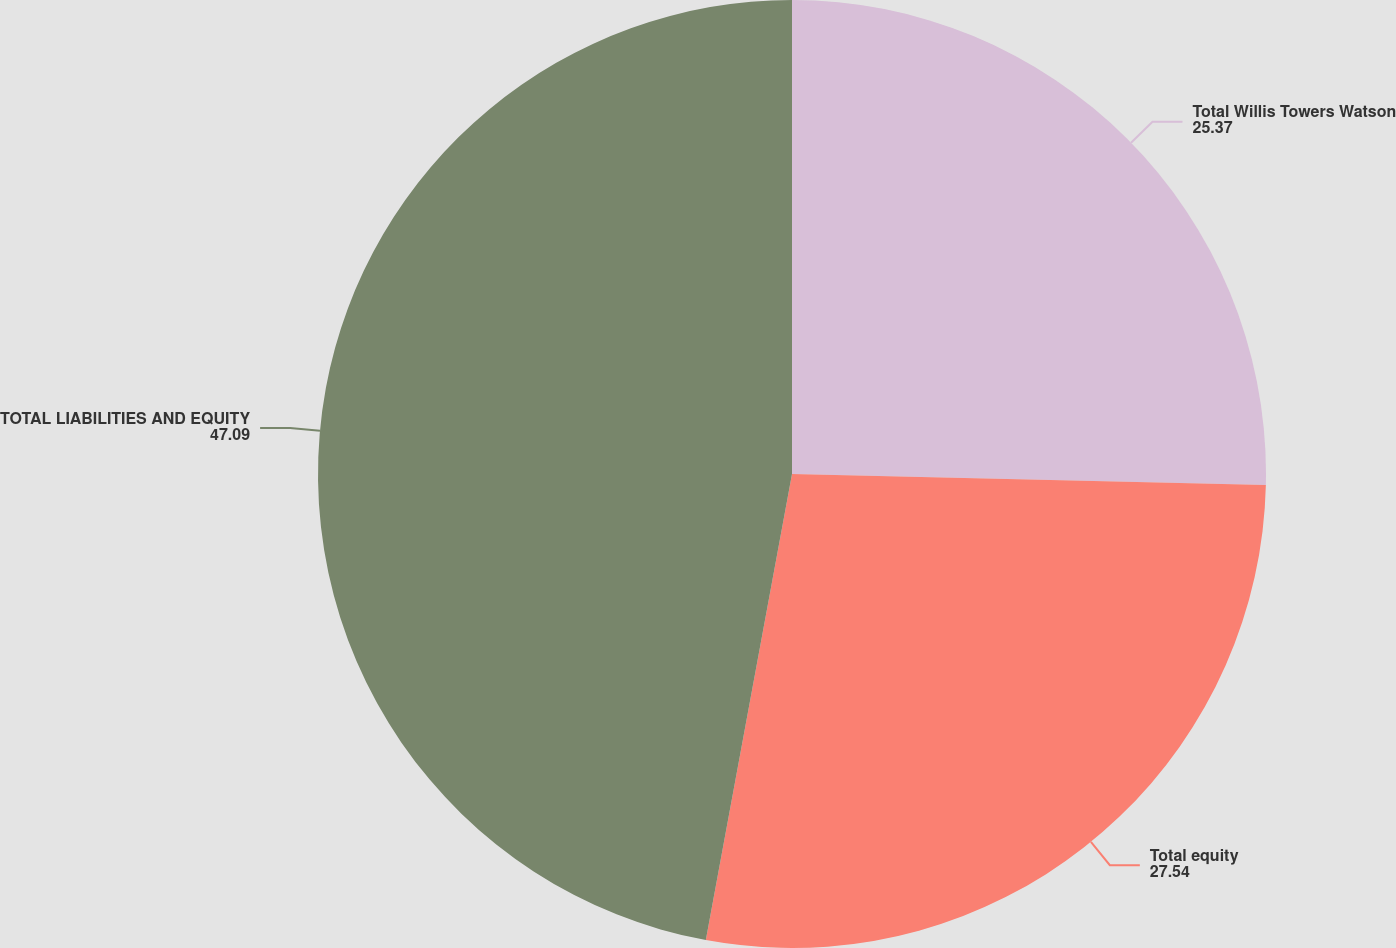Convert chart to OTSL. <chart><loc_0><loc_0><loc_500><loc_500><pie_chart><fcel>Total Willis Towers Watson<fcel>Total equity<fcel>TOTAL LIABILITIES AND EQUITY<nl><fcel>25.37%<fcel>27.54%<fcel>47.09%<nl></chart> 